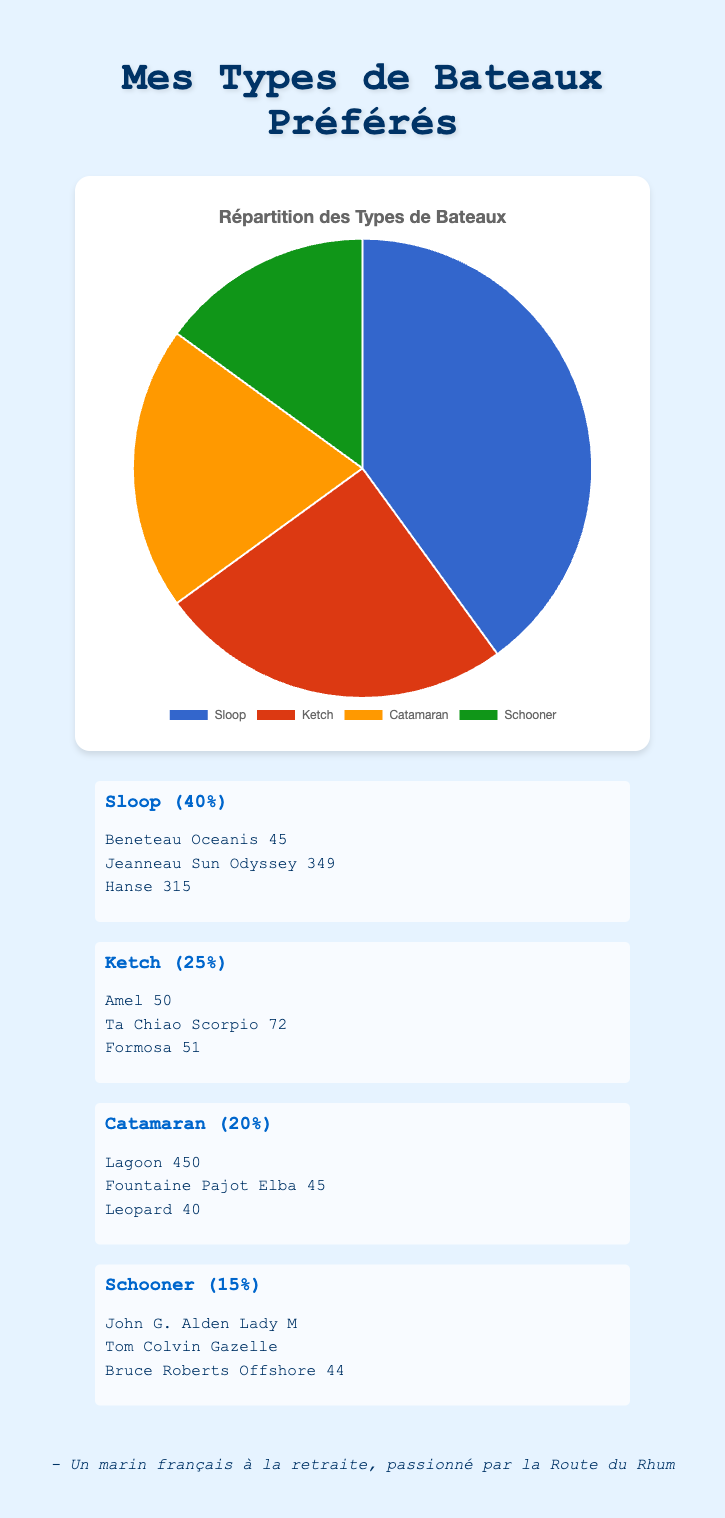Which type of boat is represented by the largest slice in the pie chart? The largest slice in the pie chart represents the boat type with the highest percentage. According to the data given, the type of boat with the highest percentage is the Sloop at 40%.
Answer: Sloop How many boats listed are Ketches? The pie chart shows the types of boats and their percentages. The detailed information reveals that there are three Ketch boats: Amel 50, Ta Chiao Scorpio 72, and Formosa 51.
Answer: 3 Which types of boats together form exactly 45% of the chart? To answer this, we need to add percentages of various boats until we reach 45%. The Ketch has 25%, and the Schooner has 15%, which sum to 40%. Adding the Schooner (15%) to the Catamaran (20%) makes 35%, which still isn't 45%. Hence, the only combination making exactly 45% is the Catamaran (20%) and Ketch (25%) added together.
Answer: Ketch and Catamaran Are there more Sloops than Catamarans in the pie chart? Yes, the pie chart shows that Sloops constitute 40% of the chart, while Catamarans make up only 20%, indicating there are more Sloops than Catamarans.
Answer: Yes If you sum the percentages of Ketch and Schooner, is it greater than, less than, or equal to the percentage of Sloops? The Ketch has 25% and the Schooner has 15%. Summing them, 25% + 15% = 40%, which is equal to the percentage of Sloops.
Answer: Equal What is the difference in percentage points between the type of boat with the largest slice and the type with the smallest slice? The largest slice represents the Sloop at 40%, and the smallest slice represents the Schooner at 15%. The difference is 40% - 15% = 25 percentage points.
Answer: 25 percentage points Which boat type is associated with the color green in the pie chart? The given code assigns colors to the boat types. The color green is associated with the Schooner.
Answer: Schooner 